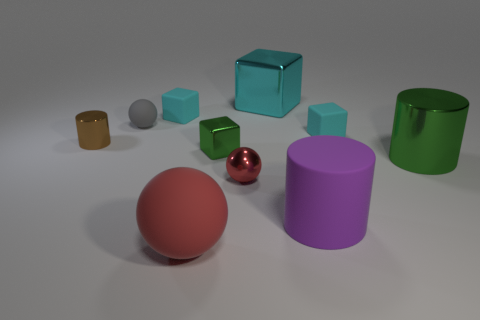Subtract all cyan cubes. How many were subtracted if there are1cyan cubes left? 2 Subtract all purple cylinders. How many cyan blocks are left? 3 Subtract all green cubes. How many cubes are left? 3 Subtract all small shiny blocks. How many blocks are left? 3 Subtract all brown cubes. Subtract all gray balls. How many cubes are left? 4 Subtract all cylinders. How many objects are left? 7 Add 5 large cyan metallic cubes. How many large cyan metallic cubes are left? 6 Add 6 small cubes. How many small cubes exist? 9 Subtract 0 green spheres. How many objects are left? 10 Subtract all big blue matte balls. Subtract all purple cylinders. How many objects are left? 9 